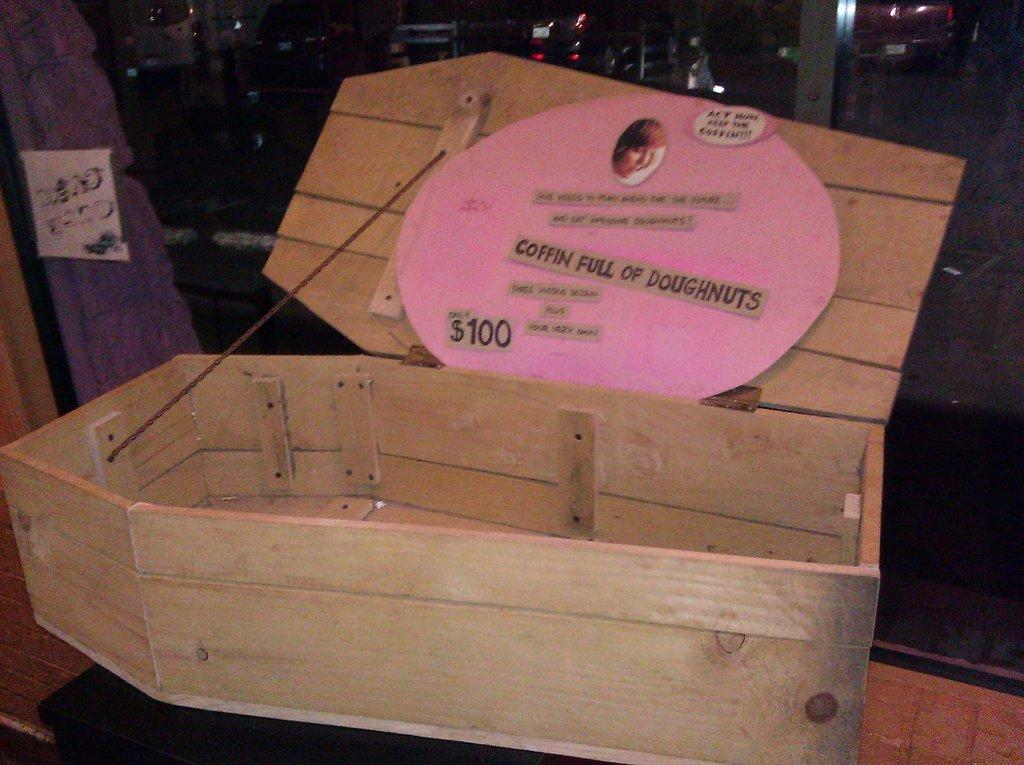<image>
Write a terse but informative summary of the picture. For $100 you can get a coffin full of doughnuts. 